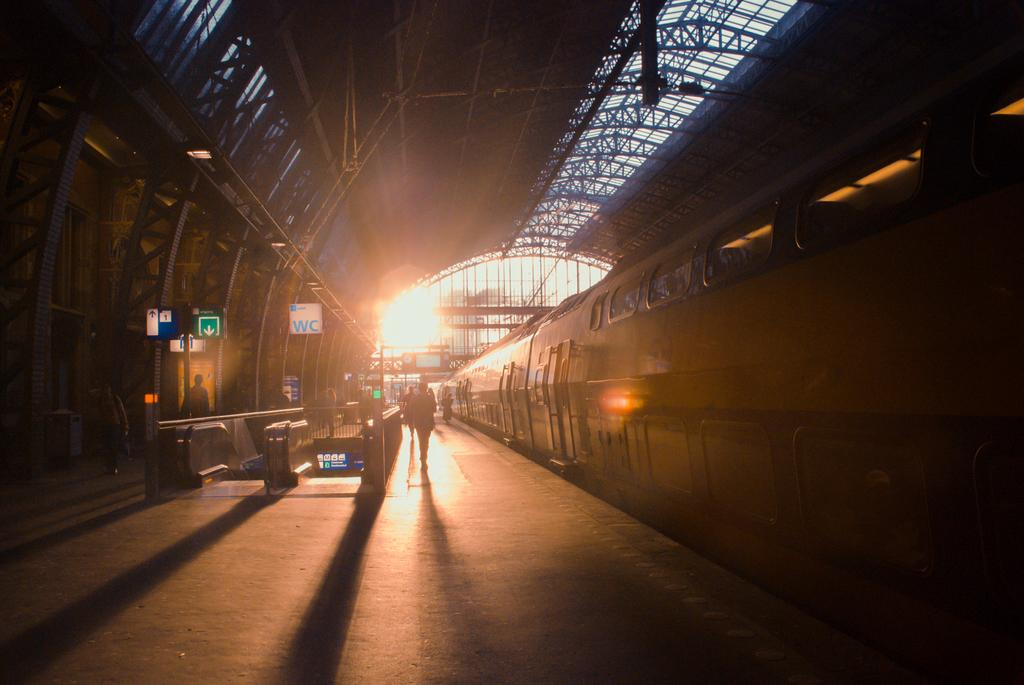Provide a one-sentence caption for the provided image. The train station has a white sign that says WC. 